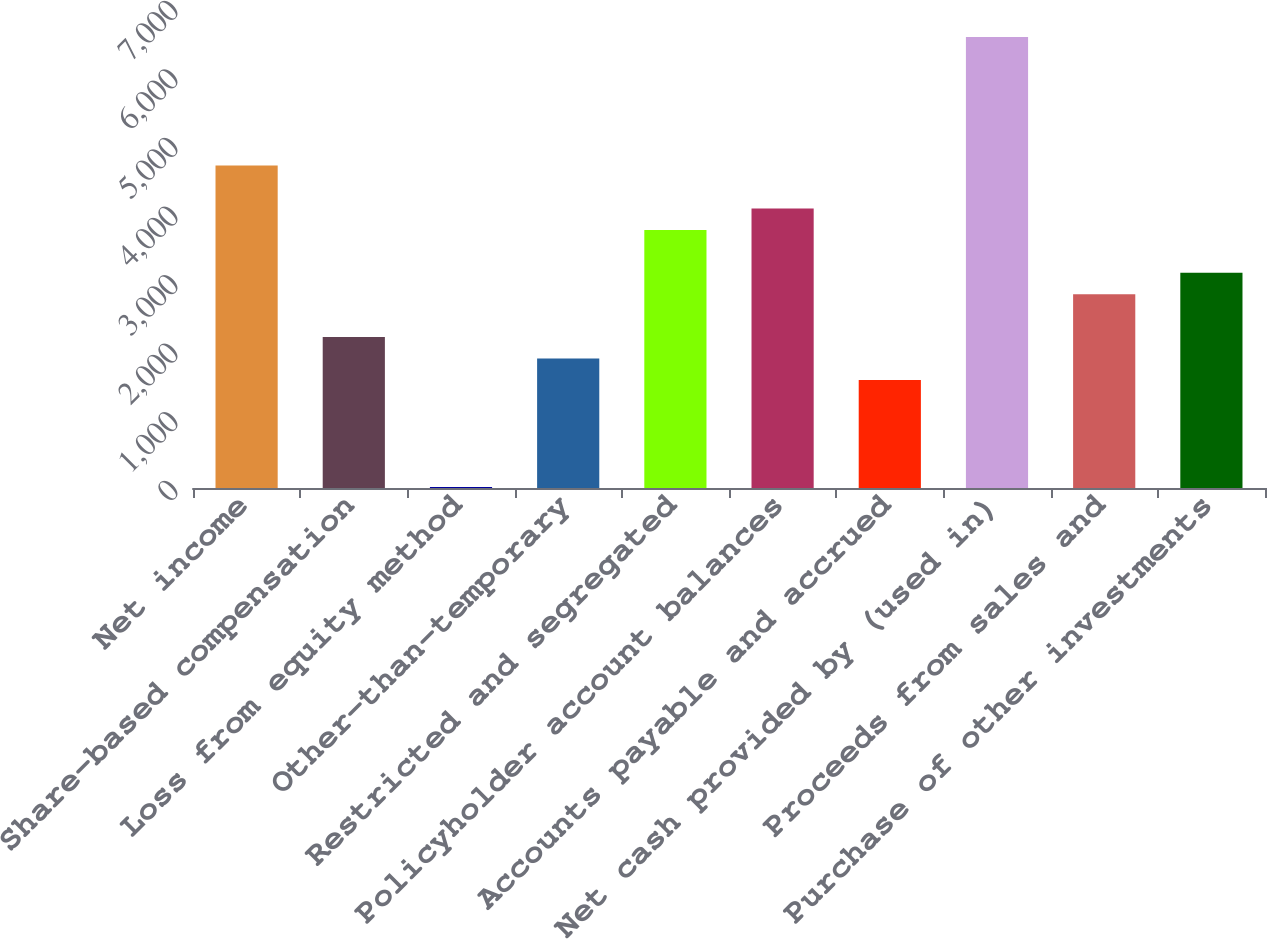<chart> <loc_0><loc_0><loc_500><loc_500><bar_chart><fcel>Net income<fcel>Share-based compensation<fcel>Loss from equity method<fcel>Other-than-temporary<fcel>Restricted and segregated<fcel>Policyholder account balances<fcel>Accounts payable and accrued<fcel>Net cash provided by (used in)<fcel>Proceeds from sales and<fcel>Purchase of other investments<nl><fcel>4701.5<fcel>2201.5<fcel>14<fcel>1889<fcel>3764<fcel>4076.5<fcel>1576.5<fcel>6576.5<fcel>2826.5<fcel>3139<nl></chart> 